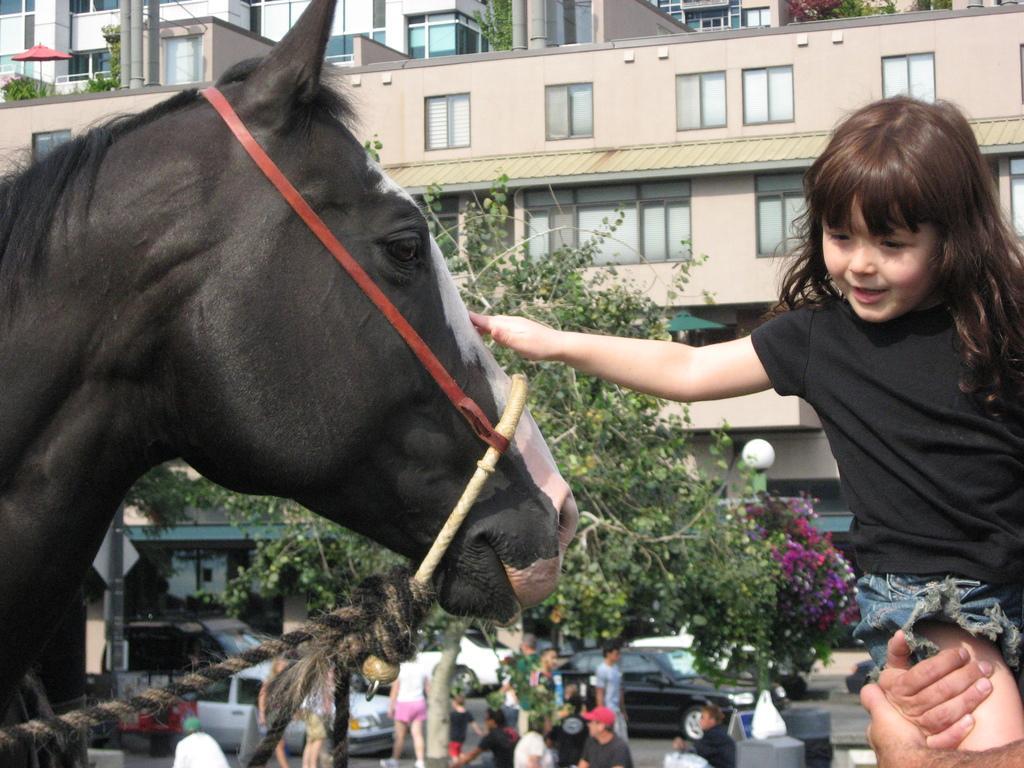Could you give a brief overview of what you see in this image? In this picture there is a small girl is touching a horse and in the backdrop they are plants and buildings 